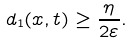<formula> <loc_0><loc_0><loc_500><loc_500>d _ { 1 } ( x , t ) \geq \frac { \eta } { 2 \varepsilon } .</formula> 